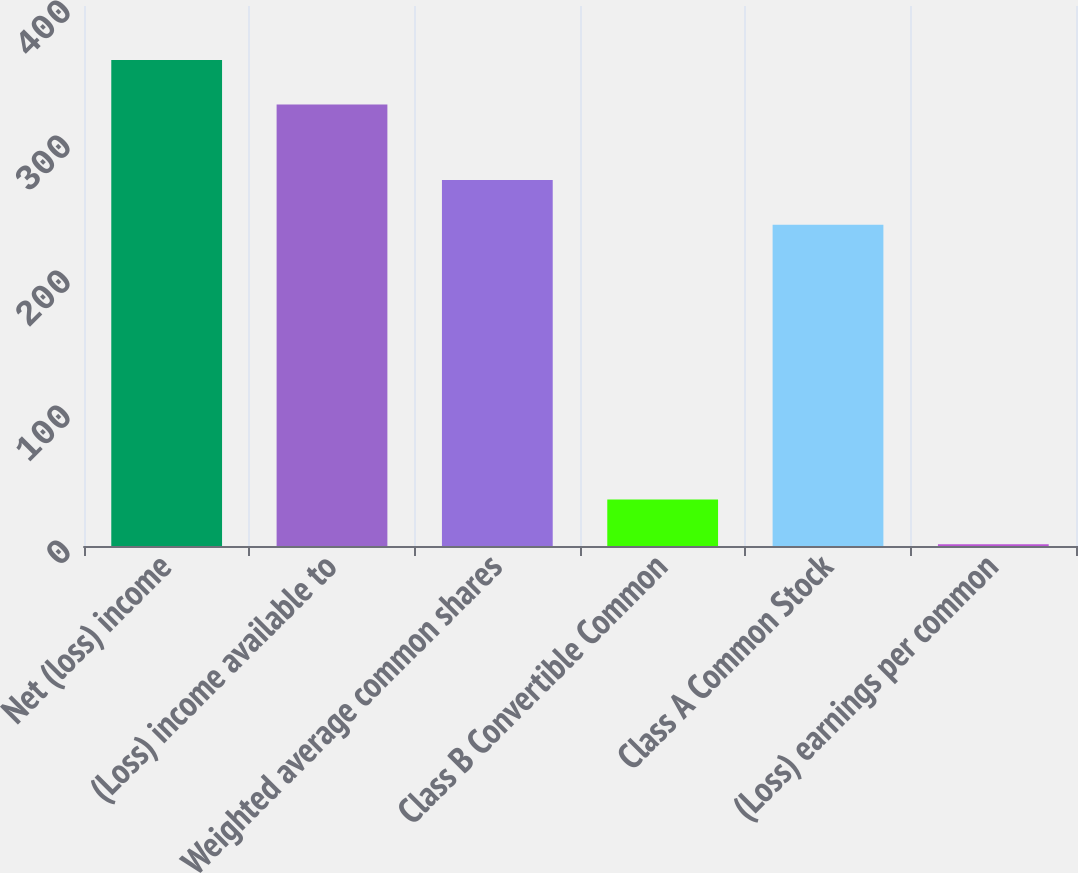Convert chart to OTSL. <chart><loc_0><loc_0><loc_500><loc_500><bar_chart><fcel>Net (loss) income<fcel>(Loss) income available to<fcel>Weighted average common shares<fcel>Class B Convertible Common<fcel>Class A Common Stock<fcel>(Loss) earnings per common<nl><fcel>360.05<fcel>327<fcel>271.07<fcel>34.43<fcel>238.02<fcel>1.38<nl></chart> 